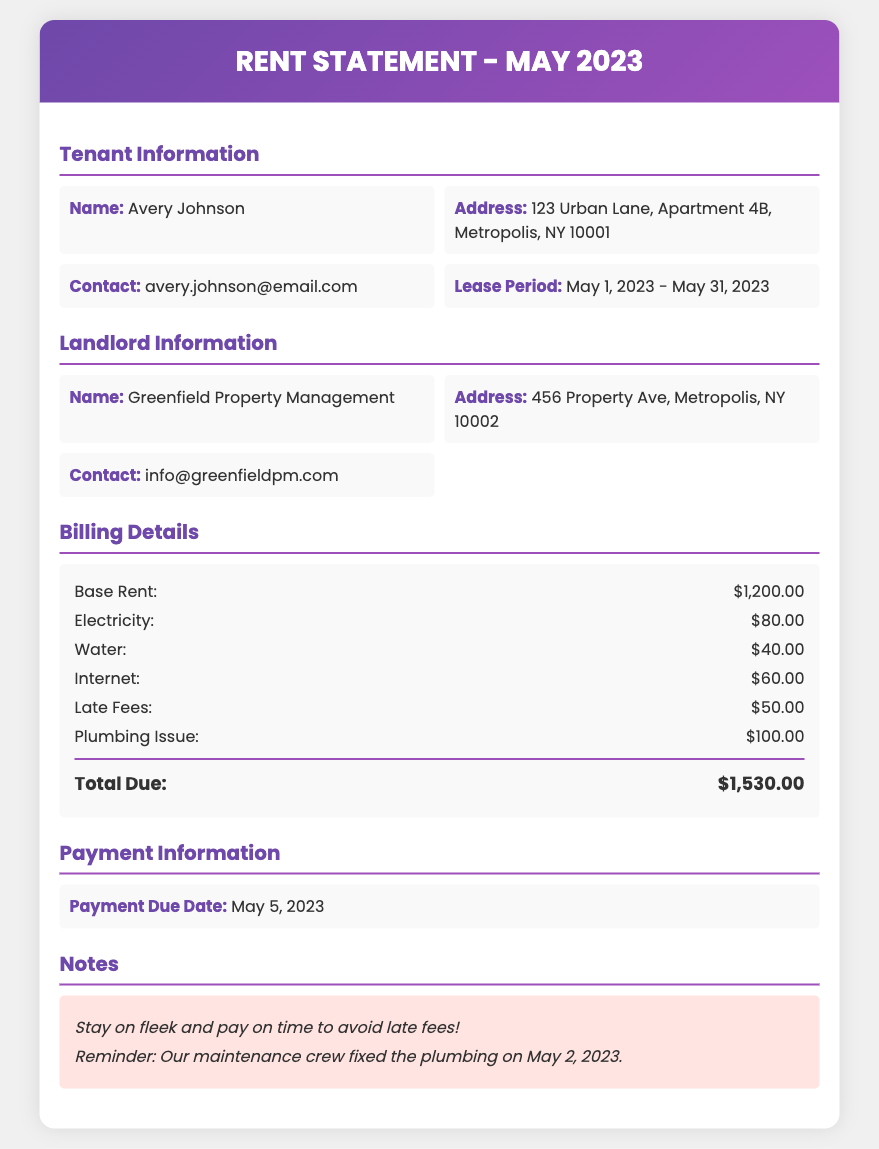what is the base rent? The base rent is listed as the amount charged for the month before any additional charges.
Answer: $1,200.00 what is the total due amount? The total due amount is the final total after including all charges and fees for the month.
Answer: $1,530.00 who is the tenant? The tenant's name is provided in the tenant information section.
Answer: Avery Johnson what is the payment due date? The payment due date indicates when the rent payment must be made to avoid late fees.
Answer: May 5, 2023 how much are the late fees? Late fees are an additional charge applied for late payment.
Answer: $50.00 what charges were included for utilities? The statement lists multiple utility charges, summing them up indicates the total utility costs.
Answer: $180.00 which maintenance issue incurred a charge? This identifies a specific maintenance problem that resulted in an additional fee on the rent statement.
Answer: Plumbing Issue who is the landlord? The landlord's name is listed in the landlord information section.
Answer: Greenfield Property Management what is the contact email for the landlord? The contact email is provided for any inquiries regarding the property or payment.
Answer: info@greenfieldpm.com 